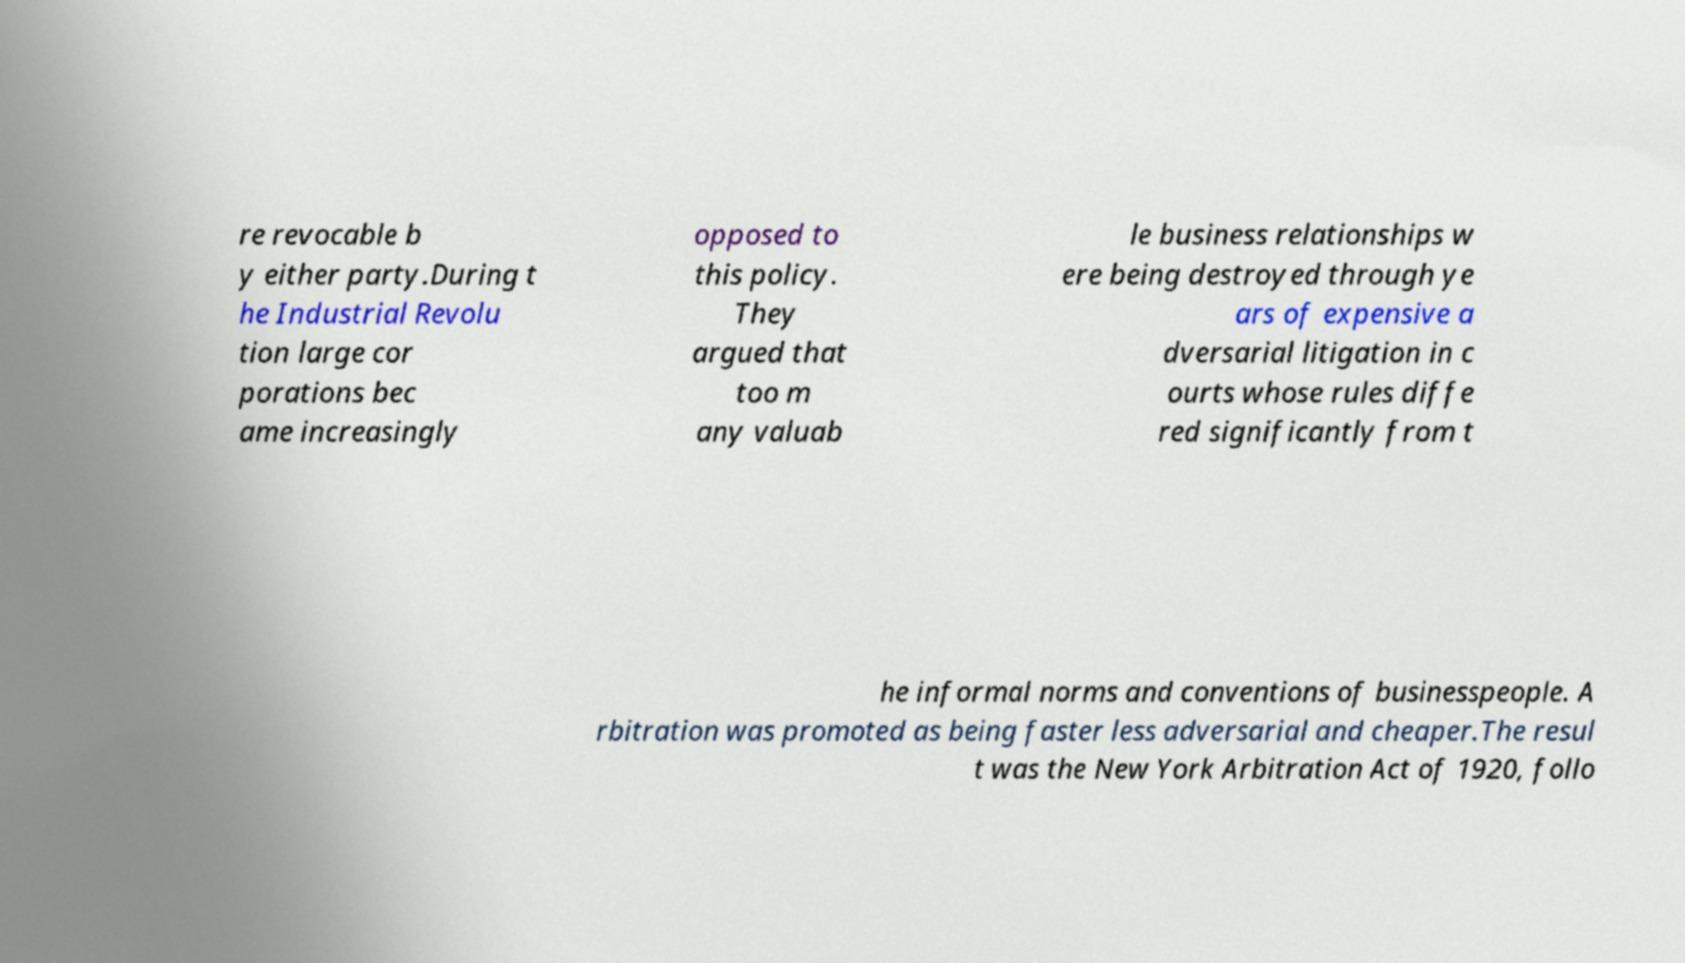Can you read and provide the text displayed in the image?This photo seems to have some interesting text. Can you extract and type it out for me? re revocable b y either party.During t he Industrial Revolu tion large cor porations bec ame increasingly opposed to this policy. They argued that too m any valuab le business relationships w ere being destroyed through ye ars of expensive a dversarial litigation in c ourts whose rules diffe red significantly from t he informal norms and conventions of businesspeople. A rbitration was promoted as being faster less adversarial and cheaper.The resul t was the New York Arbitration Act of 1920, follo 